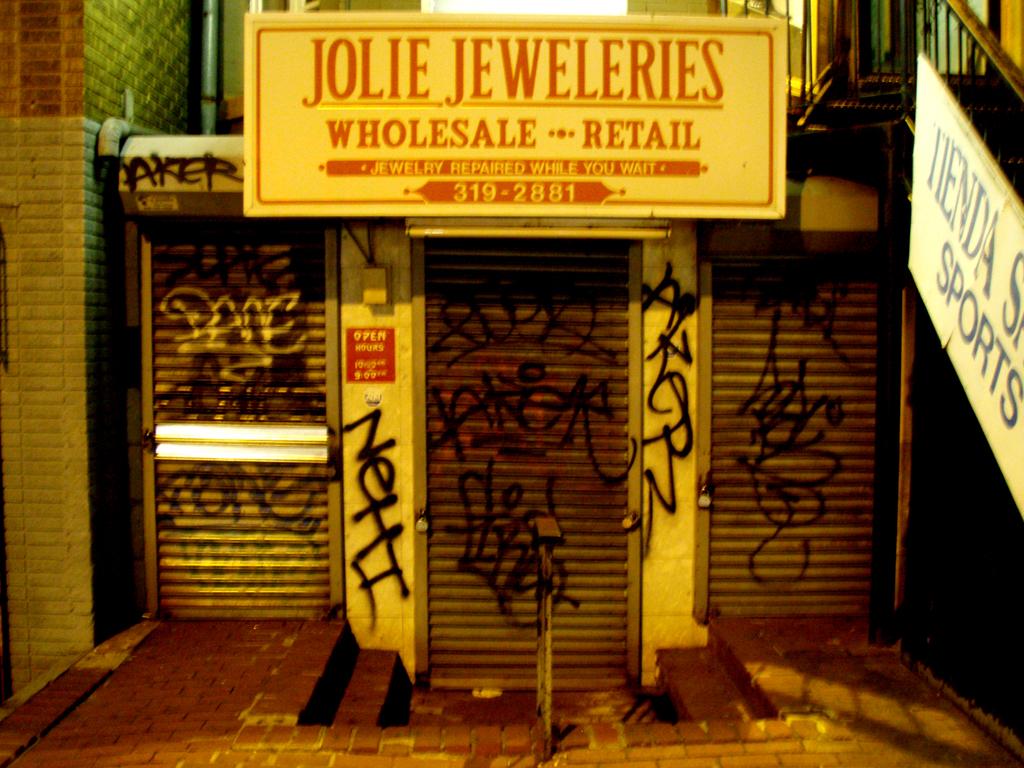Who's jeweleries is it?
Your answer should be very brief. Jolie. What is the phone number?
Your answer should be very brief. 319-2881. 